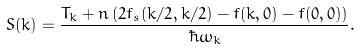<formula> <loc_0><loc_0><loc_500><loc_500>S ( k ) = \frac { T _ { k } + n \left ( 2 f _ { s } ( { k } / 2 , { k } / 2 ) - f ( { k } , 0 ) - f ( 0 , 0 ) \right ) } { \hbar { \omega } _ { k } } .</formula> 